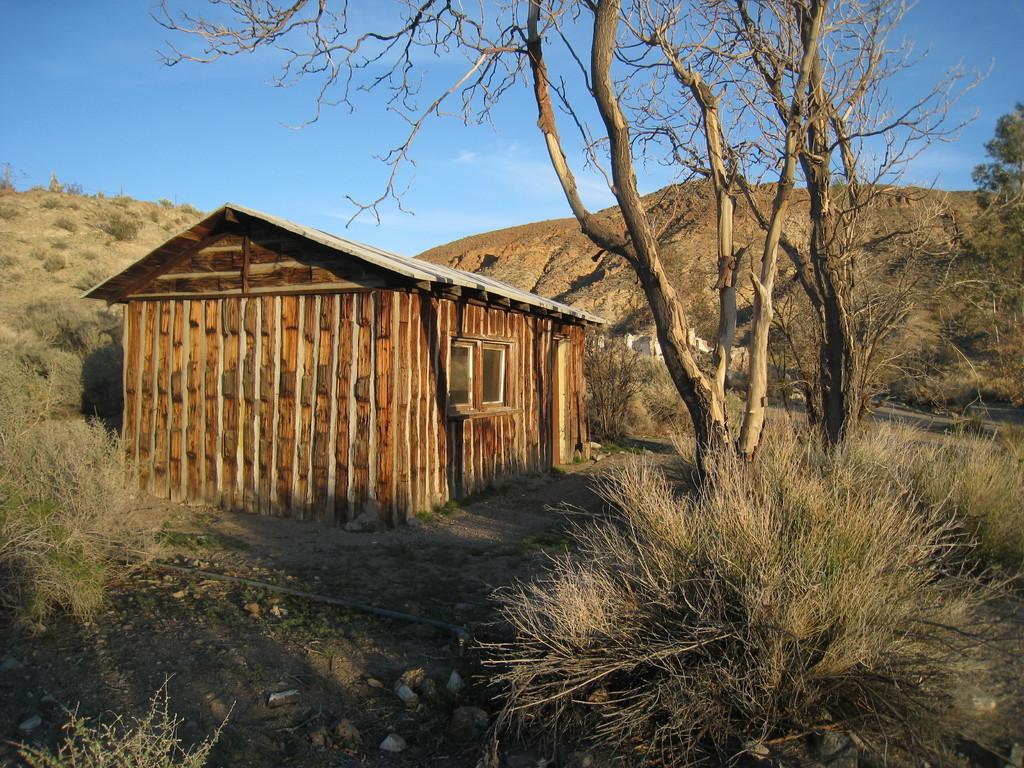What type of structure is present in the picture? There is a house in the picture. What type of vegetation can be seen in the picture? There are plants, grass, and trees in the picture. What type of landscape feature is present in the picture? There are hills in the picture. What part of the natural environment is visible in the background of the picture? The sky is visible in the background of the picture. How does the hen find its way through the hills in the picture? There is no hen present in the picture, so it is not possible to answer that question. 